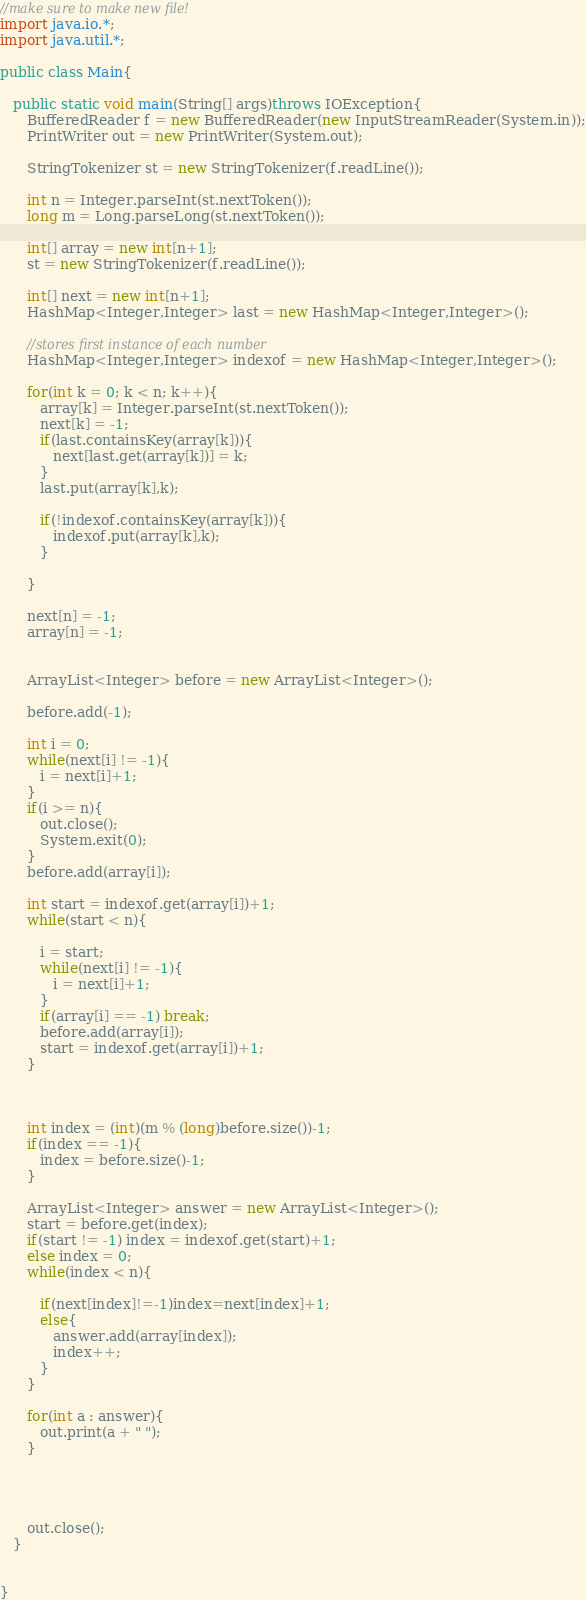<code> <loc_0><loc_0><loc_500><loc_500><_Java_>//make sure to make new file!
import java.io.*;
import java.util.*;

public class Main{
   
   public static void main(String[] args)throws IOException{
      BufferedReader f = new BufferedReader(new InputStreamReader(System.in));
      PrintWriter out = new PrintWriter(System.out);
      
      StringTokenizer st = new StringTokenizer(f.readLine());
      
      int n = Integer.parseInt(st.nextToken());
      long m = Long.parseLong(st.nextToken());
      
      int[] array = new int[n+1];
      st = new StringTokenizer(f.readLine());
      
      int[] next = new int[n+1];
      HashMap<Integer,Integer> last = new HashMap<Integer,Integer>();
      
      //stores first instance of each number
      HashMap<Integer,Integer> indexof = new HashMap<Integer,Integer>();
      
      for(int k = 0; k < n; k++){
         array[k] = Integer.parseInt(st.nextToken());
         next[k] = -1;
         if(last.containsKey(array[k])){
            next[last.get(array[k])] = k;
         }
         last.put(array[k],k);
         
         if(!indexof.containsKey(array[k])){
            indexof.put(array[k],k);
         }
         
      }
      
      next[n] = -1;
      array[n] = -1;
      
      
      ArrayList<Integer> before = new ArrayList<Integer>();
      
      before.add(-1);
      
      int i = 0;
      while(next[i] != -1){
         i = next[i]+1;
      }
      if(i >= n){
         out.close();
         System.exit(0);
      }
      before.add(array[i]);
      
      int start = indexof.get(array[i])+1;
      while(start < n){
         
         i = start;
         while(next[i] != -1){
            i = next[i]+1;
         }
         if(array[i] == -1) break;
         before.add(array[i]);
         start = indexof.get(array[i])+1;
      }

      
      
      int index = (int)(m % (long)before.size())-1;
      if(index == -1){
         index = before.size()-1;
      }
      
      ArrayList<Integer> answer = new ArrayList<Integer>();
      start = before.get(index);
      if(start != -1) index = indexof.get(start)+1;
      else index = 0;
      while(index < n){
         
         if(next[index]!=-1)index=next[index]+1; 
         else{
            answer.add(array[index]);
            index++;
         }
      }
      
      for(int a : answer){
         out.print(a + " ");
      }
      
      
      
      
      out.close();
   }
   
      
}</code> 